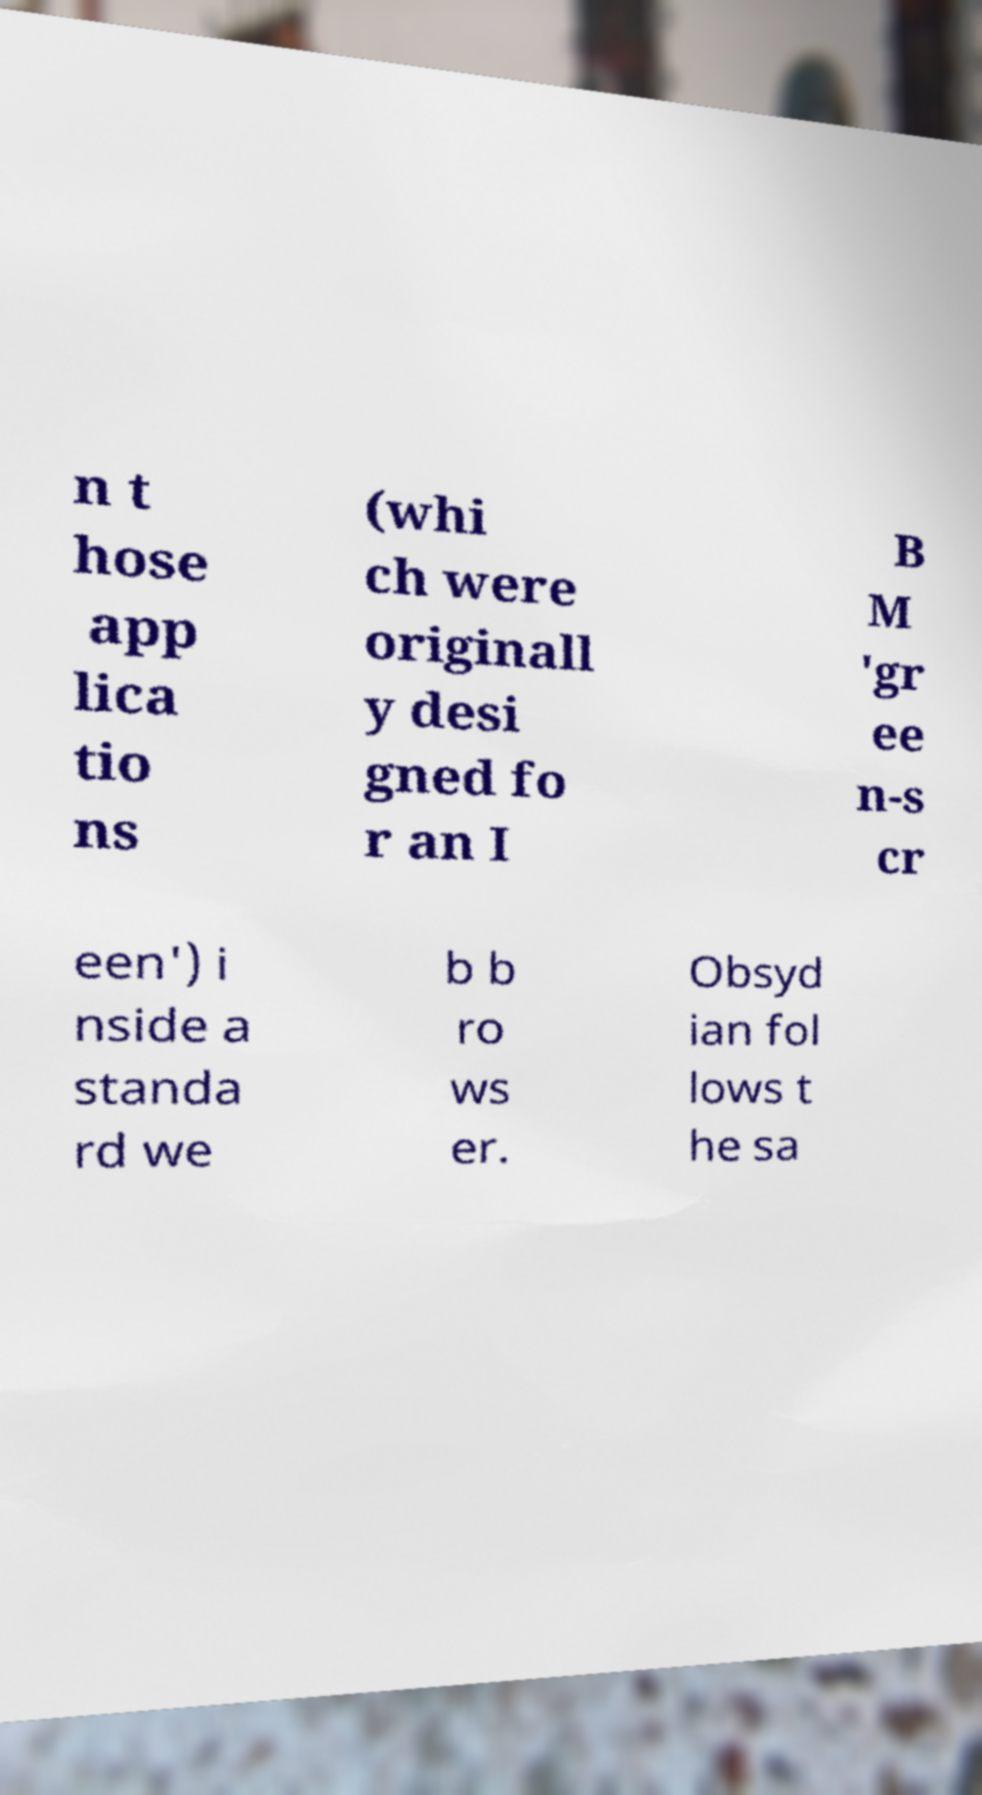Could you assist in decoding the text presented in this image and type it out clearly? n t hose app lica tio ns (whi ch were originall y desi gned fo r an I B M 'gr ee n-s cr een') i nside a standa rd we b b ro ws er. Obsyd ian fol lows t he sa 